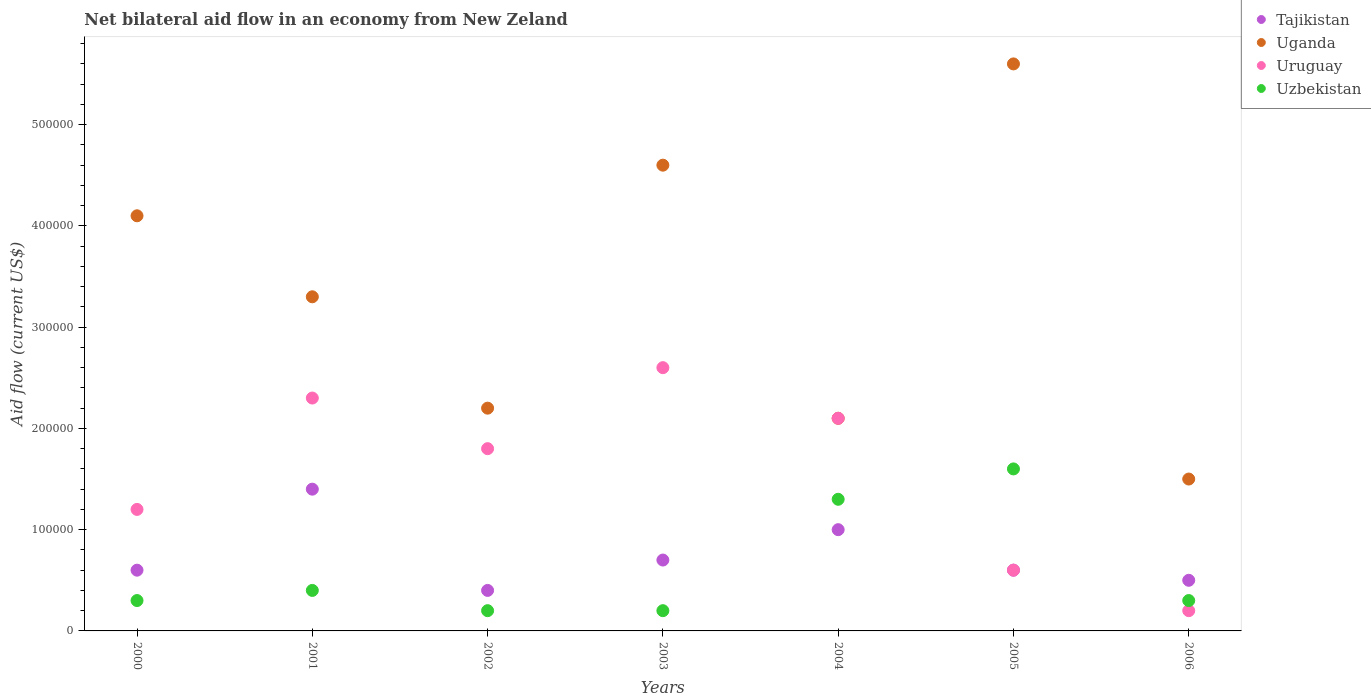How many different coloured dotlines are there?
Provide a short and direct response. 4. In which year was the net bilateral aid flow in Uruguay minimum?
Your response must be concise. 2006. What is the total net bilateral aid flow in Tajikistan in the graph?
Offer a terse response. 5.20e+05. What is the difference between the net bilateral aid flow in Uruguay in 2003 and that in 2005?
Offer a very short reply. 2.00e+05. What is the average net bilateral aid flow in Uzbekistan per year?
Provide a succinct answer. 6.14e+04. In the year 2004, what is the difference between the net bilateral aid flow in Uganda and net bilateral aid flow in Tajikistan?
Make the answer very short. 1.10e+05. In how many years, is the net bilateral aid flow in Uruguay greater than 460000 US$?
Keep it short and to the point. 0. What is the ratio of the net bilateral aid flow in Uganda in 2002 to that in 2006?
Give a very brief answer. 1.47. Is the net bilateral aid flow in Tajikistan in 2003 less than that in 2004?
Your answer should be very brief. Yes. Is the difference between the net bilateral aid flow in Uganda in 2000 and 2006 greater than the difference between the net bilateral aid flow in Tajikistan in 2000 and 2006?
Give a very brief answer. Yes. In how many years, is the net bilateral aid flow in Uruguay greater than the average net bilateral aid flow in Uruguay taken over all years?
Give a very brief answer. 4. Is the sum of the net bilateral aid flow in Uganda in 2002 and 2005 greater than the maximum net bilateral aid flow in Uzbekistan across all years?
Ensure brevity in your answer.  Yes. Is it the case that in every year, the sum of the net bilateral aid flow in Tajikistan and net bilateral aid flow in Uganda  is greater than the net bilateral aid flow in Uruguay?
Make the answer very short. Yes. Does the net bilateral aid flow in Uganda monotonically increase over the years?
Offer a terse response. No. Is the net bilateral aid flow in Uganda strictly less than the net bilateral aid flow in Uruguay over the years?
Give a very brief answer. No. How many years are there in the graph?
Your answer should be very brief. 7. What is the difference between two consecutive major ticks on the Y-axis?
Keep it short and to the point. 1.00e+05. Does the graph contain any zero values?
Offer a very short reply. No. Does the graph contain grids?
Your response must be concise. No. Where does the legend appear in the graph?
Your response must be concise. Top right. What is the title of the graph?
Offer a terse response. Net bilateral aid flow in an economy from New Zeland. Does "Azerbaijan" appear as one of the legend labels in the graph?
Your answer should be compact. No. What is the label or title of the Y-axis?
Give a very brief answer. Aid flow (current US$). What is the Aid flow (current US$) of Uzbekistan in 2000?
Provide a short and direct response. 3.00e+04. What is the Aid flow (current US$) of Uganda in 2001?
Give a very brief answer. 3.30e+05. What is the Aid flow (current US$) of Tajikistan in 2002?
Offer a terse response. 4.00e+04. What is the Aid flow (current US$) of Uganda in 2002?
Offer a terse response. 2.20e+05. What is the Aid flow (current US$) of Tajikistan in 2003?
Provide a short and direct response. 7.00e+04. What is the Aid flow (current US$) in Uruguay in 2003?
Offer a terse response. 2.60e+05. What is the Aid flow (current US$) of Tajikistan in 2004?
Provide a short and direct response. 1.00e+05. What is the Aid flow (current US$) in Uzbekistan in 2004?
Provide a succinct answer. 1.30e+05. What is the Aid flow (current US$) of Uganda in 2005?
Your answer should be compact. 5.60e+05. What is the Aid flow (current US$) in Uruguay in 2005?
Your answer should be compact. 6.00e+04. What is the Aid flow (current US$) of Uzbekistan in 2005?
Keep it short and to the point. 1.60e+05. What is the Aid flow (current US$) in Uzbekistan in 2006?
Offer a very short reply. 3.00e+04. Across all years, what is the maximum Aid flow (current US$) in Uganda?
Offer a very short reply. 5.60e+05. Across all years, what is the maximum Aid flow (current US$) of Uzbekistan?
Give a very brief answer. 1.60e+05. Across all years, what is the minimum Aid flow (current US$) of Tajikistan?
Offer a terse response. 4.00e+04. Across all years, what is the minimum Aid flow (current US$) of Uganda?
Offer a terse response. 1.50e+05. Across all years, what is the minimum Aid flow (current US$) of Uruguay?
Provide a succinct answer. 2.00e+04. What is the total Aid flow (current US$) of Tajikistan in the graph?
Give a very brief answer. 5.20e+05. What is the total Aid flow (current US$) in Uganda in the graph?
Give a very brief answer. 2.34e+06. What is the total Aid flow (current US$) of Uruguay in the graph?
Offer a terse response. 1.08e+06. What is the difference between the Aid flow (current US$) in Uganda in 2000 and that in 2001?
Ensure brevity in your answer.  8.00e+04. What is the difference between the Aid flow (current US$) of Uruguay in 2000 and that in 2001?
Give a very brief answer. -1.10e+05. What is the difference between the Aid flow (current US$) in Tajikistan in 2000 and that in 2002?
Offer a very short reply. 2.00e+04. What is the difference between the Aid flow (current US$) of Uganda in 2000 and that in 2002?
Keep it short and to the point. 1.90e+05. What is the difference between the Aid flow (current US$) of Tajikistan in 2000 and that in 2004?
Your response must be concise. -4.00e+04. What is the difference between the Aid flow (current US$) of Uzbekistan in 2000 and that in 2004?
Provide a succinct answer. -1.00e+05. What is the difference between the Aid flow (current US$) of Tajikistan in 2000 and that in 2005?
Your response must be concise. 0. What is the difference between the Aid flow (current US$) in Uruguay in 2000 and that in 2006?
Keep it short and to the point. 1.00e+05. What is the difference between the Aid flow (current US$) of Tajikistan in 2001 and that in 2002?
Keep it short and to the point. 1.00e+05. What is the difference between the Aid flow (current US$) of Uganda in 2001 and that in 2002?
Keep it short and to the point. 1.10e+05. What is the difference between the Aid flow (current US$) in Uzbekistan in 2001 and that in 2002?
Give a very brief answer. 2.00e+04. What is the difference between the Aid flow (current US$) in Uganda in 2001 and that in 2003?
Provide a short and direct response. -1.30e+05. What is the difference between the Aid flow (current US$) of Tajikistan in 2001 and that in 2004?
Offer a terse response. 4.00e+04. What is the difference between the Aid flow (current US$) in Uganda in 2001 and that in 2004?
Keep it short and to the point. 1.20e+05. What is the difference between the Aid flow (current US$) of Uganda in 2001 and that in 2005?
Provide a short and direct response. -2.30e+05. What is the difference between the Aid flow (current US$) of Tajikistan in 2001 and that in 2006?
Your response must be concise. 9.00e+04. What is the difference between the Aid flow (current US$) in Uganda in 2001 and that in 2006?
Your answer should be very brief. 1.80e+05. What is the difference between the Aid flow (current US$) of Uzbekistan in 2001 and that in 2006?
Your answer should be very brief. 10000. What is the difference between the Aid flow (current US$) of Tajikistan in 2002 and that in 2003?
Keep it short and to the point. -3.00e+04. What is the difference between the Aid flow (current US$) of Uruguay in 2002 and that in 2003?
Keep it short and to the point. -8.00e+04. What is the difference between the Aid flow (current US$) in Uzbekistan in 2002 and that in 2003?
Offer a terse response. 0. What is the difference between the Aid flow (current US$) in Uzbekistan in 2002 and that in 2004?
Provide a succinct answer. -1.10e+05. What is the difference between the Aid flow (current US$) of Uzbekistan in 2002 and that in 2005?
Ensure brevity in your answer.  -1.40e+05. What is the difference between the Aid flow (current US$) in Uganda in 2002 and that in 2006?
Your answer should be compact. 7.00e+04. What is the difference between the Aid flow (current US$) of Uruguay in 2002 and that in 2006?
Ensure brevity in your answer.  1.60e+05. What is the difference between the Aid flow (current US$) of Uzbekistan in 2002 and that in 2006?
Offer a terse response. -10000. What is the difference between the Aid flow (current US$) in Uruguay in 2003 and that in 2005?
Make the answer very short. 2.00e+05. What is the difference between the Aid flow (current US$) of Uzbekistan in 2003 and that in 2005?
Give a very brief answer. -1.40e+05. What is the difference between the Aid flow (current US$) of Tajikistan in 2003 and that in 2006?
Your answer should be very brief. 2.00e+04. What is the difference between the Aid flow (current US$) in Tajikistan in 2004 and that in 2005?
Make the answer very short. 4.00e+04. What is the difference between the Aid flow (current US$) of Uganda in 2004 and that in 2005?
Give a very brief answer. -3.50e+05. What is the difference between the Aid flow (current US$) of Uruguay in 2004 and that in 2005?
Offer a terse response. 1.50e+05. What is the difference between the Aid flow (current US$) of Uruguay in 2004 and that in 2006?
Provide a succinct answer. 1.90e+05. What is the difference between the Aid flow (current US$) in Uganda in 2005 and that in 2006?
Make the answer very short. 4.10e+05. What is the difference between the Aid flow (current US$) of Uruguay in 2005 and that in 2006?
Provide a short and direct response. 4.00e+04. What is the difference between the Aid flow (current US$) of Uzbekistan in 2005 and that in 2006?
Your answer should be very brief. 1.30e+05. What is the difference between the Aid flow (current US$) in Tajikistan in 2000 and the Aid flow (current US$) in Uruguay in 2001?
Your answer should be compact. -1.70e+05. What is the difference between the Aid flow (current US$) in Uruguay in 2000 and the Aid flow (current US$) in Uzbekistan in 2001?
Provide a short and direct response. 8.00e+04. What is the difference between the Aid flow (current US$) in Uganda in 2000 and the Aid flow (current US$) in Uzbekistan in 2002?
Provide a short and direct response. 3.90e+05. What is the difference between the Aid flow (current US$) of Tajikistan in 2000 and the Aid flow (current US$) of Uganda in 2003?
Provide a succinct answer. -4.00e+05. What is the difference between the Aid flow (current US$) in Uganda in 2000 and the Aid flow (current US$) in Uruguay in 2003?
Your response must be concise. 1.50e+05. What is the difference between the Aid flow (current US$) of Uruguay in 2000 and the Aid flow (current US$) of Uzbekistan in 2003?
Ensure brevity in your answer.  1.00e+05. What is the difference between the Aid flow (current US$) in Tajikistan in 2000 and the Aid flow (current US$) in Uruguay in 2004?
Offer a terse response. -1.50e+05. What is the difference between the Aid flow (current US$) in Tajikistan in 2000 and the Aid flow (current US$) in Uzbekistan in 2004?
Ensure brevity in your answer.  -7.00e+04. What is the difference between the Aid flow (current US$) of Uruguay in 2000 and the Aid flow (current US$) of Uzbekistan in 2004?
Keep it short and to the point. -10000. What is the difference between the Aid flow (current US$) in Tajikistan in 2000 and the Aid flow (current US$) in Uganda in 2005?
Make the answer very short. -5.00e+05. What is the difference between the Aid flow (current US$) of Uganda in 2000 and the Aid flow (current US$) of Uruguay in 2005?
Your response must be concise. 3.50e+05. What is the difference between the Aid flow (current US$) of Uganda in 2000 and the Aid flow (current US$) of Uzbekistan in 2005?
Your answer should be compact. 2.50e+05. What is the difference between the Aid flow (current US$) in Uruguay in 2000 and the Aid flow (current US$) in Uzbekistan in 2005?
Your answer should be compact. -4.00e+04. What is the difference between the Aid flow (current US$) in Tajikistan in 2000 and the Aid flow (current US$) in Uganda in 2006?
Keep it short and to the point. -9.00e+04. What is the difference between the Aid flow (current US$) of Tajikistan in 2000 and the Aid flow (current US$) of Uruguay in 2006?
Make the answer very short. 4.00e+04. What is the difference between the Aid flow (current US$) in Uganda in 2000 and the Aid flow (current US$) in Uruguay in 2006?
Ensure brevity in your answer.  3.90e+05. What is the difference between the Aid flow (current US$) in Uganda in 2000 and the Aid flow (current US$) in Uzbekistan in 2006?
Offer a very short reply. 3.80e+05. What is the difference between the Aid flow (current US$) in Tajikistan in 2001 and the Aid flow (current US$) in Uganda in 2002?
Provide a succinct answer. -8.00e+04. What is the difference between the Aid flow (current US$) in Tajikistan in 2001 and the Aid flow (current US$) in Uzbekistan in 2002?
Offer a terse response. 1.20e+05. What is the difference between the Aid flow (current US$) of Uruguay in 2001 and the Aid flow (current US$) of Uzbekistan in 2002?
Your answer should be compact. 2.10e+05. What is the difference between the Aid flow (current US$) of Tajikistan in 2001 and the Aid flow (current US$) of Uganda in 2003?
Offer a terse response. -3.20e+05. What is the difference between the Aid flow (current US$) in Tajikistan in 2001 and the Aid flow (current US$) in Uruguay in 2003?
Offer a terse response. -1.20e+05. What is the difference between the Aid flow (current US$) in Uganda in 2001 and the Aid flow (current US$) in Uzbekistan in 2003?
Provide a short and direct response. 3.10e+05. What is the difference between the Aid flow (current US$) in Tajikistan in 2001 and the Aid flow (current US$) in Uganda in 2004?
Make the answer very short. -7.00e+04. What is the difference between the Aid flow (current US$) in Uganda in 2001 and the Aid flow (current US$) in Uruguay in 2004?
Your answer should be very brief. 1.20e+05. What is the difference between the Aid flow (current US$) in Uruguay in 2001 and the Aid flow (current US$) in Uzbekistan in 2004?
Your answer should be compact. 1.00e+05. What is the difference between the Aid flow (current US$) of Tajikistan in 2001 and the Aid flow (current US$) of Uganda in 2005?
Make the answer very short. -4.20e+05. What is the difference between the Aid flow (current US$) of Tajikistan in 2001 and the Aid flow (current US$) of Uruguay in 2005?
Your response must be concise. 8.00e+04. What is the difference between the Aid flow (current US$) in Uruguay in 2001 and the Aid flow (current US$) in Uzbekistan in 2005?
Your response must be concise. 7.00e+04. What is the difference between the Aid flow (current US$) in Tajikistan in 2001 and the Aid flow (current US$) in Uruguay in 2006?
Provide a short and direct response. 1.20e+05. What is the difference between the Aid flow (current US$) in Tajikistan in 2001 and the Aid flow (current US$) in Uzbekistan in 2006?
Your answer should be very brief. 1.10e+05. What is the difference between the Aid flow (current US$) in Uganda in 2001 and the Aid flow (current US$) in Uruguay in 2006?
Give a very brief answer. 3.10e+05. What is the difference between the Aid flow (current US$) in Uganda in 2001 and the Aid flow (current US$) in Uzbekistan in 2006?
Your response must be concise. 3.00e+05. What is the difference between the Aid flow (current US$) in Uruguay in 2001 and the Aid flow (current US$) in Uzbekistan in 2006?
Provide a short and direct response. 2.00e+05. What is the difference between the Aid flow (current US$) in Tajikistan in 2002 and the Aid flow (current US$) in Uganda in 2003?
Provide a short and direct response. -4.20e+05. What is the difference between the Aid flow (current US$) in Tajikistan in 2002 and the Aid flow (current US$) in Uruguay in 2003?
Offer a terse response. -2.20e+05. What is the difference between the Aid flow (current US$) in Tajikistan in 2002 and the Aid flow (current US$) in Uzbekistan in 2003?
Offer a very short reply. 2.00e+04. What is the difference between the Aid flow (current US$) in Uganda in 2002 and the Aid flow (current US$) in Uruguay in 2004?
Ensure brevity in your answer.  10000. What is the difference between the Aid flow (current US$) of Uganda in 2002 and the Aid flow (current US$) of Uzbekistan in 2004?
Offer a terse response. 9.00e+04. What is the difference between the Aid flow (current US$) in Uruguay in 2002 and the Aid flow (current US$) in Uzbekistan in 2004?
Make the answer very short. 5.00e+04. What is the difference between the Aid flow (current US$) of Tajikistan in 2002 and the Aid flow (current US$) of Uganda in 2005?
Offer a very short reply. -5.20e+05. What is the difference between the Aid flow (current US$) in Uganda in 2002 and the Aid flow (current US$) in Uruguay in 2005?
Ensure brevity in your answer.  1.60e+05. What is the difference between the Aid flow (current US$) of Tajikistan in 2002 and the Aid flow (current US$) of Uganda in 2006?
Your answer should be very brief. -1.10e+05. What is the difference between the Aid flow (current US$) of Tajikistan in 2002 and the Aid flow (current US$) of Uzbekistan in 2006?
Offer a very short reply. 10000. What is the difference between the Aid flow (current US$) in Uganda in 2002 and the Aid flow (current US$) in Uzbekistan in 2006?
Your answer should be very brief. 1.90e+05. What is the difference between the Aid flow (current US$) in Tajikistan in 2003 and the Aid flow (current US$) in Uruguay in 2004?
Provide a short and direct response. -1.40e+05. What is the difference between the Aid flow (current US$) of Tajikistan in 2003 and the Aid flow (current US$) of Uzbekistan in 2004?
Keep it short and to the point. -6.00e+04. What is the difference between the Aid flow (current US$) in Tajikistan in 2003 and the Aid flow (current US$) in Uganda in 2005?
Ensure brevity in your answer.  -4.90e+05. What is the difference between the Aid flow (current US$) of Tajikistan in 2003 and the Aid flow (current US$) of Uruguay in 2005?
Your response must be concise. 10000. What is the difference between the Aid flow (current US$) in Tajikistan in 2003 and the Aid flow (current US$) in Uzbekistan in 2005?
Provide a short and direct response. -9.00e+04. What is the difference between the Aid flow (current US$) in Uganda in 2003 and the Aid flow (current US$) in Uruguay in 2005?
Give a very brief answer. 4.00e+05. What is the difference between the Aid flow (current US$) of Uganda in 2003 and the Aid flow (current US$) of Uzbekistan in 2005?
Your answer should be compact. 3.00e+05. What is the difference between the Aid flow (current US$) of Uruguay in 2003 and the Aid flow (current US$) of Uzbekistan in 2005?
Your answer should be compact. 1.00e+05. What is the difference between the Aid flow (current US$) of Tajikistan in 2003 and the Aid flow (current US$) of Uzbekistan in 2006?
Provide a succinct answer. 4.00e+04. What is the difference between the Aid flow (current US$) in Uganda in 2003 and the Aid flow (current US$) in Uruguay in 2006?
Ensure brevity in your answer.  4.40e+05. What is the difference between the Aid flow (current US$) of Uganda in 2003 and the Aid flow (current US$) of Uzbekistan in 2006?
Ensure brevity in your answer.  4.30e+05. What is the difference between the Aid flow (current US$) in Uruguay in 2003 and the Aid flow (current US$) in Uzbekistan in 2006?
Provide a short and direct response. 2.30e+05. What is the difference between the Aid flow (current US$) of Tajikistan in 2004 and the Aid flow (current US$) of Uganda in 2005?
Keep it short and to the point. -4.60e+05. What is the difference between the Aid flow (current US$) in Tajikistan in 2004 and the Aid flow (current US$) in Uruguay in 2005?
Your answer should be compact. 4.00e+04. What is the difference between the Aid flow (current US$) in Tajikistan in 2004 and the Aid flow (current US$) in Uzbekistan in 2005?
Provide a succinct answer. -6.00e+04. What is the difference between the Aid flow (current US$) in Uganda in 2004 and the Aid flow (current US$) in Uruguay in 2005?
Provide a short and direct response. 1.50e+05. What is the difference between the Aid flow (current US$) of Uganda in 2004 and the Aid flow (current US$) of Uzbekistan in 2005?
Offer a terse response. 5.00e+04. What is the difference between the Aid flow (current US$) of Tajikistan in 2004 and the Aid flow (current US$) of Uruguay in 2006?
Keep it short and to the point. 8.00e+04. What is the difference between the Aid flow (current US$) in Tajikistan in 2004 and the Aid flow (current US$) in Uzbekistan in 2006?
Ensure brevity in your answer.  7.00e+04. What is the difference between the Aid flow (current US$) in Uganda in 2004 and the Aid flow (current US$) in Uruguay in 2006?
Ensure brevity in your answer.  1.90e+05. What is the difference between the Aid flow (current US$) in Tajikistan in 2005 and the Aid flow (current US$) in Uganda in 2006?
Your answer should be compact. -9.00e+04. What is the difference between the Aid flow (current US$) in Tajikistan in 2005 and the Aid flow (current US$) in Uruguay in 2006?
Keep it short and to the point. 4.00e+04. What is the difference between the Aid flow (current US$) in Tajikistan in 2005 and the Aid flow (current US$) in Uzbekistan in 2006?
Your response must be concise. 3.00e+04. What is the difference between the Aid flow (current US$) of Uganda in 2005 and the Aid flow (current US$) of Uruguay in 2006?
Offer a terse response. 5.40e+05. What is the difference between the Aid flow (current US$) in Uganda in 2005 and the Aid flow (current US$) in Uzbekistan in 2006?
Ensure brevity in your answer.  5.30e+05. What is the average Aid flow (current US$) of Tajikistan per year?
Provide a short and direct response. 7.43e+04. What is the average Aid flow (current US$) of Uganda per year?
Provide a succinct answer. 3.34e+05. What is the average Aid flow (current US$) in Uruguay per year?
Offer a very short reply. 1.54e+05. What is the average Aid flow (current US$) in Uzbekistan per year?
Your answer should be very brief. 6.14e+04. In the year 2000, what is the difference between the Aid flow (current US$) of Tajikistan and Aid flow (current US$) of Uganda?
Ensure brevity in your answer.  -3.50e+05. In the year 2000, what is the difference between the Aid flow (current US$) in Tajikistan and Aid flow (current US$) in Uzbekistan?
Ensure brevity in your answer.  3.00e+04. In the year 2000, what is the difference between the Aid flow (current US$) of Uganda and Aid flow (current US$) of Uzbekistan?
Your response must be concise. 3.80e+05. In the year 2001, what is the difference between the Aid flow (current US$) of Tajikistan and Aid flow (current US$) of Uganda?
Offer a very short reply. -1.90e+05. In the year 2001, what is the difference between the Aid flow (current US$) in Tajikistan and Aid flow (current US$) in Uruguay?
Provide a succinct answer. -9.00e+04. In the year 2001, what is the difference between the Aid flow (current US$) in Tajikistan and Aid flow (current US$) in Uzbekistan?
Make the answer very short. 1.00e+05. In the year 2001, what is the difference between the Aid flow (current US$) of Uruguay and Aid flow (current US$) of Uzbekistan?
Your answer should be very brief. 1.90e+05. In the year 2002, what is the difference between the Aid flow (current US$) in Uganda and Aid flow (current US$) in Uzbekistan?
Your answer should be compact. 2.00e+05. In the year 2002, what is the difference between the Aid flow (current US$) of Uruguay and Aid flow (current US$) of Uzbekistan?
Your answer should be very brief. 1.60e+05. In the year 2003, what is the difference between the Aid flow (current US$) of Tajikistan and Aid flow (current US$) of Uganda?
Your answer should be very brief. -3.90e+05. In the year 2003, what is the difference between the Aid flow (current US$) in Tajikistan and Aid flow (current US$) in Uzbekistan?
Offer a very short reply. 5.00e+04. In the year 2003, what is the difference between the Aid flow (current US$) of Uruguay and Aid flow (current US$) of Uzbekistan?
Your answer should be very brief. 2.40e+05. In the year 2004, what is the difference between the Aid flow (current US$) in Uganda and Aid flow (current US$) in Uruguay?
Offer a very short reply. 0. In the year 2004, what is the difference between the Aid flow (current US$) in Uruguay and Aid flow (current US$) in Uzbekistan?
Keep it short and to the point. 8.00e+04. In the year 2005, what is the difference between the Aid flow (current US$) in Tajikistan and Aid flow (current US$) in Uganda?
Keep it short and to the point. -5.00e+05. In the year 2005, what is the difference between the Aid flow (current US$) of Uganda and Aid flow (current US$) of Uruguay?
Ensure brevity in your answer.  5.00e+05. In the year 2005, what is the difference between the Aid flow (current US$) of Uganda and Aid flow (current US$) of Uzbekistan?
Your answer should be very brief. 4.00e+05. In the year 2006, what is the difference between the Aid flow (current US$) of Tajikistan and Aid flow (current US$) of Uruguay?
Provide a succinct answer. 3.00e+04. In the year 2006, what is the difference between the Aid flow (current US$) of Uganda and Aid flow (current US$) of Uruguay?
Ensure brevity in your answer.  1.30e+05. In the year 2006, what is the difference between the Aid flow (current US$) of Uganda and Aid flow (current US$) of Uzbekistan?
Provide a succinct answer. 1.20e+05. What is the ratio of the Aid flow (current US$) in Tajikistan in 2000 to that in 2001?
Provide a short and direct response. 0.43. What is the ratio of the Aid flow (current US$) of Uganda in 2000 to that in 2001?
Your response must be concise. 1.24. What is the ratio of the Aid flow (current US$) in Uruguay in 2000 to that in 2001?
Your answer should be very brief. 0.52. What is the ratio of the Aid flow (current US$) of Uzbekistan in 2000 to that in 2001?
Provide a short and direct response. 0.75. What is the ratio of the Aid flow (current US$) of Tajikistan in 2000 to that in 2002?
Offer a terse response. 1.5. What is the ratio of the Aid flow (current US$) of Uganda in 2000 to that in 2002?
Keep it short and to the point. 1.86. What is the ratio of the Aid flow (current US$) in Uzbekistan in 2000 to that in 2002?
Give a very brief answer. 1.5. What is the ratio of the Aid flow (current US$) of Tajikistan in 2000 to that in 2003?
Make the answer very short. 0.86. What is the ratio of the Aid flow (current US$) in Uganda in 2000 to that in 2003?
Your response must be concise. 0.89. What is the ratio of the Aid flow (current US$) in Uruguay in 2000 to that in 2003?
Your answer should be compact. 0.46. What is the ratio of the Aid flow (current US$) in Uzbekistan in 2000 to that in 2003?
Ensure brevity in your answer.  1.5. What is the ratio of the Aid flow (current US$) in Tajikistan in 2000 to that in 2004?
Offer a terse response. 0.6. What is the ratio of the Aid flow (current US$) in Uganda in 2000 to that in 2004?
Offer a very short reply. 1.95. What is the ratio of the Aid flow (current US$) in Uruguay in 2000 to that in 2004?
Your response must be concise. 0.57. What is the ratio of the Aid flow (current US$) of Uzbekistan in 2000 to that in 2004?
Give a very brief answer. 0.23. What is the ratio of the Aid flow (current US$) of Uganda in 2000 to that in 2005?
Offer a terse response. 0.73. What is the ratio of the Aid flow (current US$) of Uruguay in 2000 to that in 2005?
Your answer should be compact. 2. What is the ratio of the Aid flow (current US$) in Uzbekistan in 2000 to that in 2005?
Your response must be concise. 0.19. What is the ratio of the Aid flow (current US$) of Uganda in 2000 to that in 2006?
Make the answer very short. 2.73. What is the ratio of the Aid flow (current US$) of Uzbekistan in 2000 to that in 2006?
Your answer should be very brief. 1. What is the ratio of the Aid flow (current US$) of Uruguay in 2001 to that in 2002?
Give a very brief answer. 1.28. What is the ratio of the Aid flow (current US$) of Tajikistan in 2001 to that in 2003?
Make the answer very short. 2. What is the ratio of the Aid flow (current US$) of Uganda in 2001 to that in 2003?
Your answer should be very brief. 0.72. What is the ratio of the Aid flow (current US$) in Uruguay in 2001 to that in 2003?
Your answer should be very brief. 0.88. What is the ratio of the Aid flow (current US$) of Uzbekistan in 2001 to that in 2003?
Provide a succinct answer. 2. What is the ratio of the Aid flow (current US$) of Tajikistan in 2001 to that in 2004?
Your response must be concise. 1.4. What is the ratio of the Aid flow (current US$) of Uganda in 2001 to that in 2004?
Your answer should be compact. 1.57. What is the ratio of the Aid flow (current US$) of Uruguay in 2001 to that in 2004?
Your response must be concise. 1.1. What is the ratio of the Aid flow (current US$) of Uzbekistan in 2001 to that in 2004?
Ensure brevity in your answer.  0.31. What is the ratio of the Aid flow (current US$) in Tajikistan in 2001 to that in 2005?
Your answer should be compact. 2.33. What is the ratio of the Aid flow (current US$) of Uganda in 2001 to that in 2005?
Your answer should be compact. 0.59. What is the ratio of the Aid flow (current US$) of Uruguay in 2001 to that in 2005?
Provide a short and direct response. 3.83. What is the ratio of the Aid flow (current US$) in Uzbekistan in 2001 to that in 2006?
Provide a short and direct response. 1.33. What is the ratio of the Aid flow (current US$) in Uganda in 2002 to that in 2003?
Keep it short and to the point. 0.48. What is the ratio of the Aid flow (current US$) of Uruguay in 2002 to that in 2003?
Offer a terse response. 0.69. What is the ratio of the Aid flow (current US$) in Uzbekistan in 2002 to that in 2003?
Ensure brevity in your answer.  1. What is the ratio of the Aid flow (current US$) in Uganda in 2002 to that in 2004?
Offer a very short reply. 1.05. What is the ratio of the Aid flow (current US$) of Uzbekistan in 2002 to that in 2004?
Your answer should be very brief. 0.15. What is the ratio of the Aid flow (current US$) of Tajikistan in 2002 to that in 2005?
Provide a short and direct response. 0.67. What is the ratio of the Aid flow (current US$) in Uganda in 2002 to that in 2005?
Your answer should be compact. 0.39. What is the ratio of the Aid flow (current US$) of Tajikistan in 2002 to that in 2006?
Your answer should be compact. 0.8. What is the ratio of the Aid flow (current US$) in Uganda in 2002 to that in 2006?
Offer a terse response. 1.47. What is the ratio of the Aid flow (current US$) of Uruguay in 2002 to that in 2006?
Provide a succinct answer. 9. What is the ratio of the Aid flow (current US$) in Tajikistan in 2003 to that in 2004?
Your response must be concise. 0.7. What is the ratio of the Aid flow (current US$) of Uganda in 2003 to that in 2004?
Make the answer very short. 2.19. What is the ratio of the Aid flow (current US$) in Uruguay in 2003 to that in 2004?
Your answer should be very brief. 1.24. What is the ratio of the Aid flow (current US$) of Uzbekistan in 2003 to that in 2004?
Provide a short and direct response. 0.15. What is the ratio of the Aid flow (current US$) of Uganda in 2003 to that in 2005?
Give a very brief answer. 0.82. What is the ratio of the Aid flow (current US$) of Uruguay in 2003 to that in 2005?
Your answer should be very brief. 4.33. What is the ratio of the Aid flow (current US$) of Tajikistan in 2003 to that in 2006?
Offer a very short reply. 1.4. What is the ratio of the Aid flow (current US$) of Uganda in 2003 to that in 2006?
Provide a succinct answer. 3.07. What is the ratio of the Aid flow (current US$) of Uzbekistan in 2003 to that in 2006?
Provide a succinct answer. 0.67. What is the ratio of the Aid flow (current US$) of Uganda in 2004 to that in 2005?
Provide a short and direct response. 0.38. What is the ratio of the Aid flow (current US$) of Uzbekistan in 2004 to that in 2005?
Provide a short and direct response. 0.81. What is the ratio of the Aid flow (current US$) of Tajikistan in 2004 to that in 2006?
Provide a short and direct response. 2. What is the ratio of the Aid flow (current US$) in Uganda in 2004 to that in 2006?
Your answer should be compact. 1.4. What is the ratio of the Aid flow (current US$) in Uruguay in 2004 to that in 2006?
Provide a short and direct response. 10.5. What is the ratio of the Aid flow (current US$) in Uzbekistan in 2004 to that in 2006?
Your answer should be very brief. 4.33. What is the ratio of the Aid flow (current US$) of Uganda in 2005 to that in 2006?
Your answer should be compact. 3.73. What is the ratio of the Aid flow (current US$) of Uruguay in 2005 to that in 2006?
Give a very brief answer. 3. What is the ratio of the Aid flow (current US$) in Uzbekistan in 2005 to that in 2006?
Your answer should be very brief. 5.33. What is the difference between the highest and the second highest Aid flow (current US$) in Uganda?
Offer a terse response. 1.00e+05. What is the difference between the highest and the second highest Aid flow (current US$) in Uruguay?
Ensure brevity in your answer.  3.00e+04. What is the difference between the highest and the second highest Aid flow (current US$) of Uzbekistan?
Your answer should be compact. 3.00e+04. What is the difference between the highest and the lowest Aid flow (current US$) of Tajikistan?
Make the answer very short. 1.00e+05. What is the difference between the highest and the lowest Aid flow (current US$) in Uruguay?
Provide a succinct answer. 2.40e+05. 